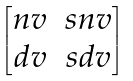Convert formula to latex. <formula><loc_0><loc_0><loc_500><loc_500>\begin{bmatrix} n v & s n v \\ d v & s d v \end{bmatrix}</formula> 